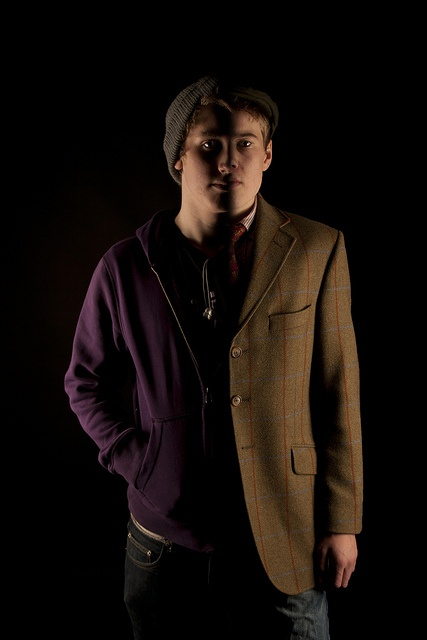Describe the objects in this image and their specific colors. I can see people in black, maroon, and gray tones and tie in black, maroon, and brown tones in this image. 